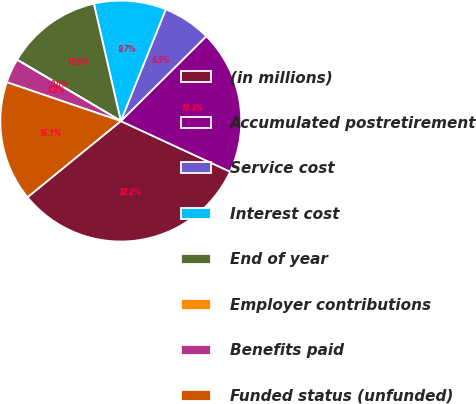Convert chart to OTSL. <chart><loc_0><loc_0><loc_500><loc_500><pie_chart><fcel>(in millions)<fcel>Accumulated postretirement<fcel>Service cost<fcel>Interest cost<fcel>End of year<fcel>Employer contributions<fcel>Benefits paid<fcel>Funded status (unfunded)<nl><fcel>32.21%<fcel>19.34%<fcel>6.47%<fcel>9.68%<fcel>12.9%<fcel>0.03%<fcel>3.25%<fcel>16.12%<nl></chart> 